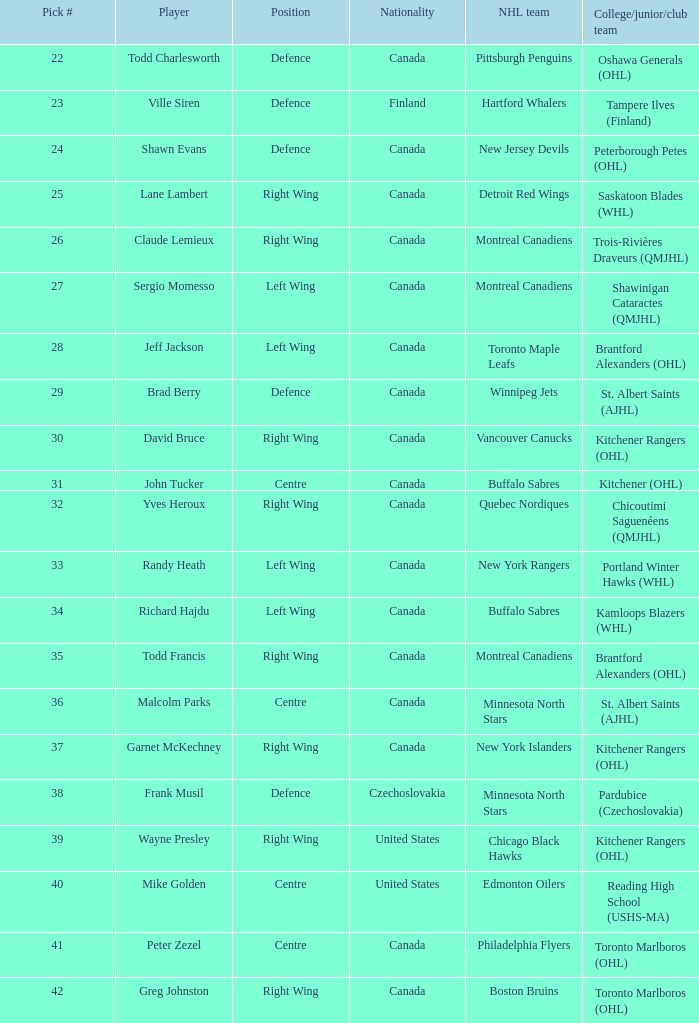How many times is the nhl team the winnipeg jets? 1.0. 